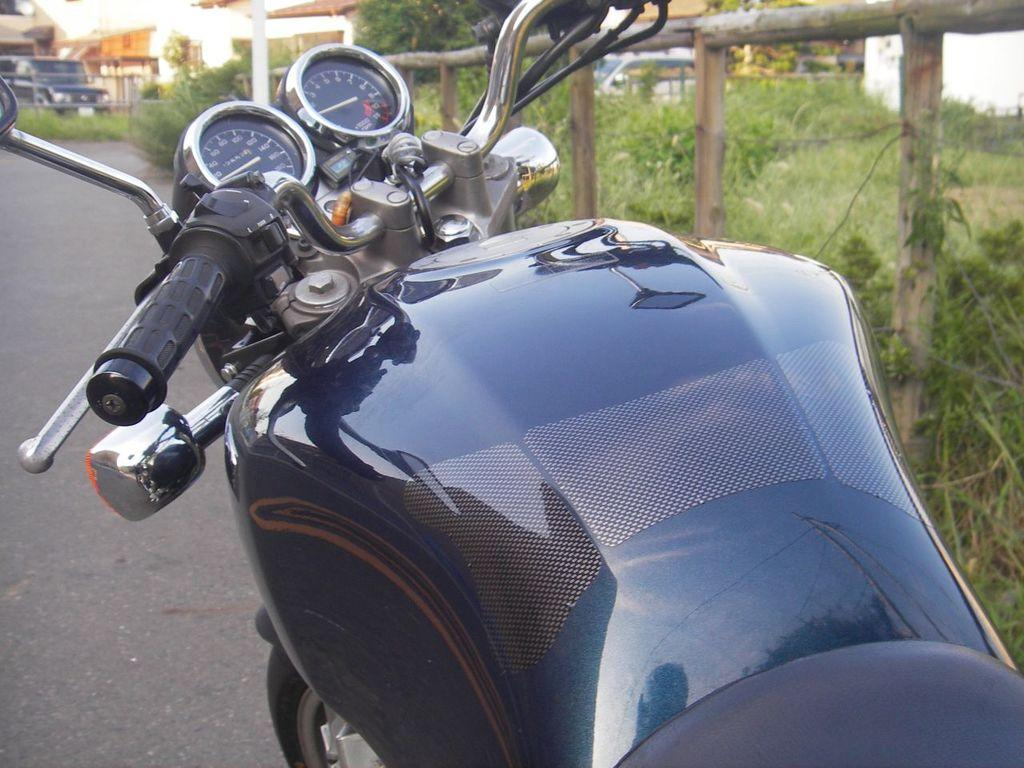What vehicle is present in the image? There is a motorcycle in the image. What type of barrier can be seen in the image? There is a wooden fence in the image. What type of vegetation is on the left side of the image? There are plants on the left side of the image. What other vehicle is present in the image? There is a car in the image. What can be seen in the distance in the image? There are buildings in the background of the image. How many weeks does the monkey take to finish the wooden fence in the image? There is no monkey present in the image, and therefore no such activity can be observed. What day of the week is it in the image? The day of the week cannot be determined from the image. 